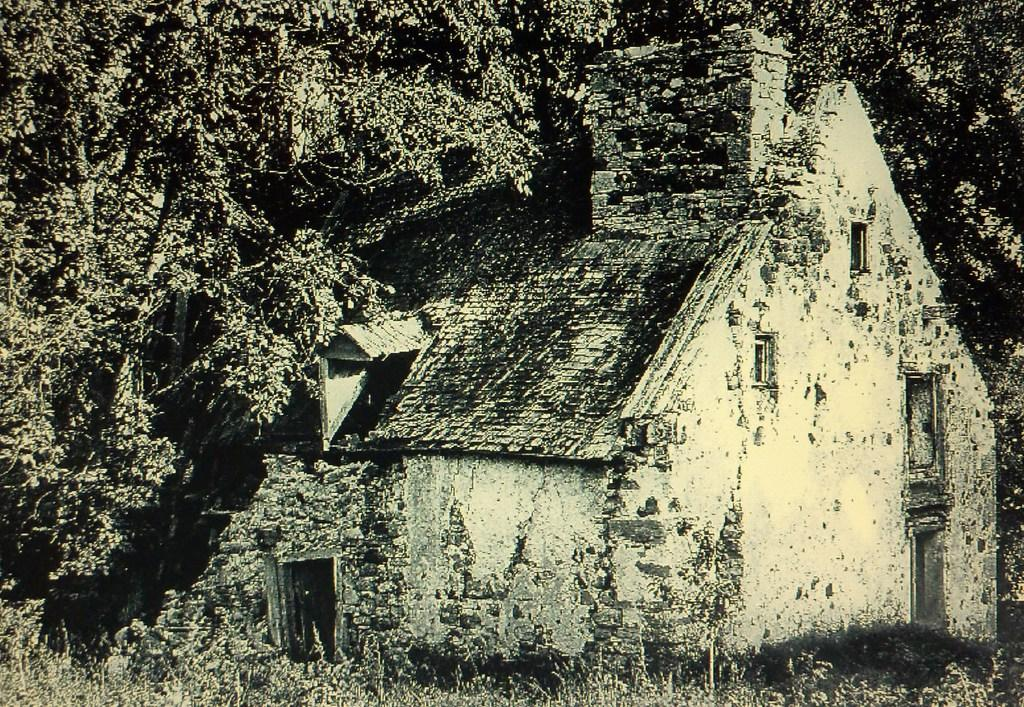What type of house is in the image? There is an old house in the image. What material is used for the roof of the house? The roof of the house is made of bricks. What type of vegetation is present in the image? There are small plants in the image. What can be seen in the background of the image? There are trees in the background of the image. What type of insect is crawling on the parent's shoulder in the image? There is no insect or parent present in the image; it only features an old house, small plants, and trees in the background. 